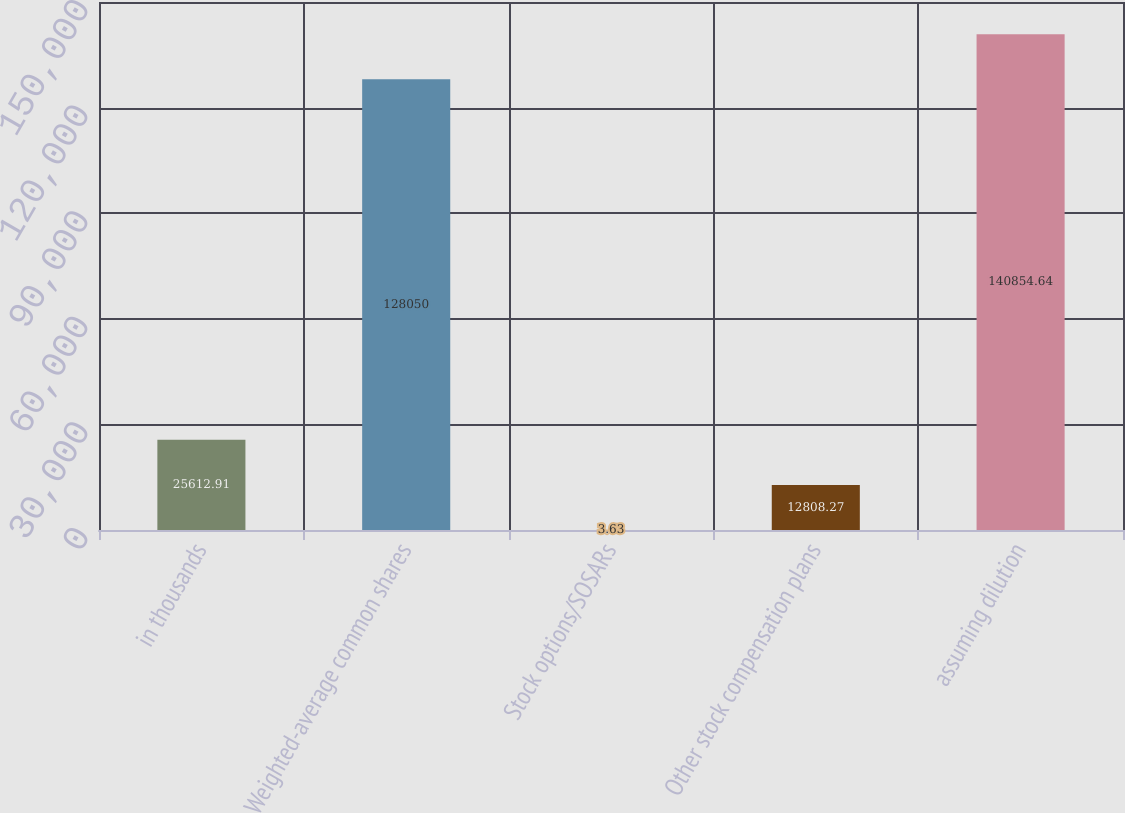Convert chart to OTSL. <chart><loc_0><loc_0><loc_500><loc_500><bar_chart><fcel>in thousands<fcel>Weighted-average common shares<fcel>Stock options/SOSARs<fcel>Other stock compensation plans<fcel>assuming dilution<nl><fcel>25612.9<fcel>128050<fcel>3.63<fcel>12808.3<fcel>140855<nl></chart> 